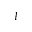Convert formula to latex. <formula><loc_0><loc_0><loc_500><loc_500>I</formula> 